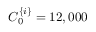<formula> <loc_0><loc_0><loc_500><loc_500>C _ { 0 } ^ { \{ i \} } = 1 2 , 0 0 0</formula> 